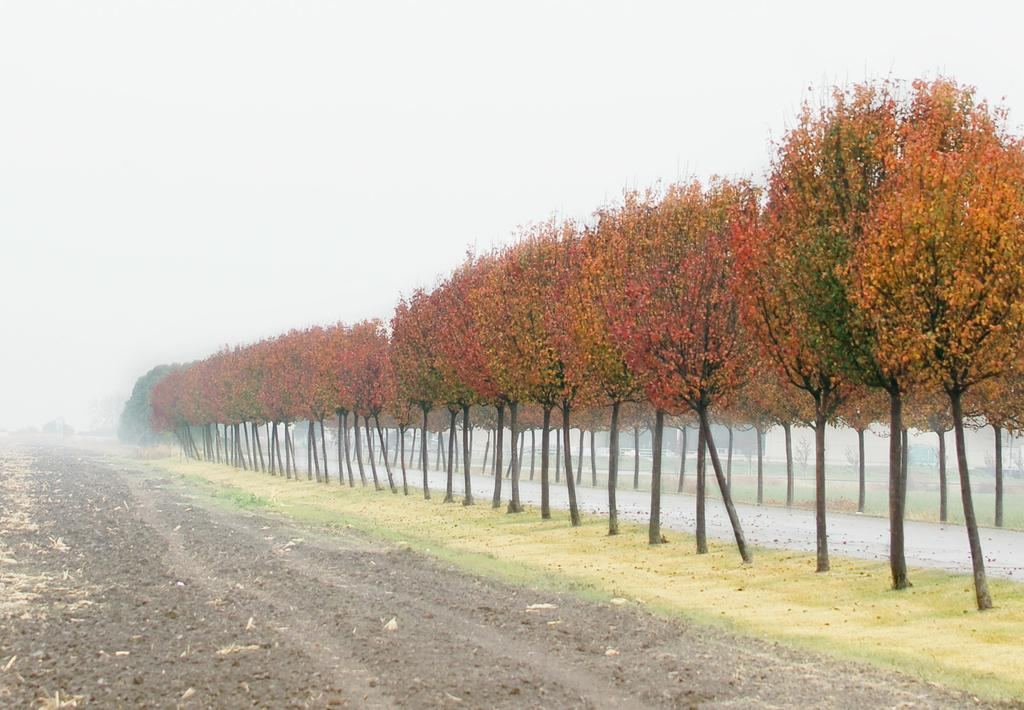What type of terrain is visible at the bottom of the image? There is soil and grass at the bottom of the picture. What can be seen on the right side of the image? There are trees on the right side of the image. How would you describe the background of the image? The background is covered with fog, and the sky is visible. What direction does the harmony take in the image? There is no harmony present in the image, as it is a visual representation of a landscape with soil, grass, trees, fog, and sky. 